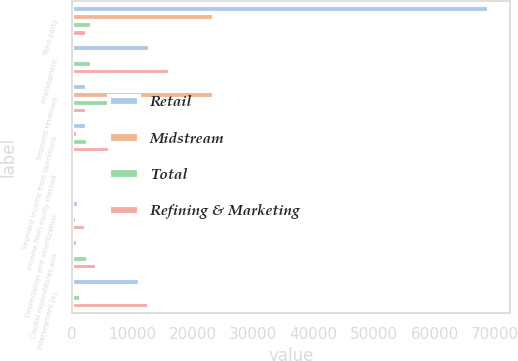Convert chart to OTSL. <chart><loc_0><loc_0><loc_500><loc_500><stacked_bar_chart><ecel><fcel>Third party<fcel>Intersegment<fcel>Segment revenues<fcel>Segment income from operations<fcel>Income from equity method<fcel>Depreciation and amortization<fcel>Capital expenditures and<fcel>Intersegment (a)<nl><fcel>Retail<fcel>68939<fcel>12914<fcel>2481<fcel>2481<fcel>15<fcel>1174<fcel>1057<fcel>11309<nl><fcel>Midstream<fcel>23538<fcel>6<fcel>23552<fcel>1028<fcel>74<fcel>353<fcel>460<fcel>4<nl><fcel>Total<fcel>3273<fcel>3387<fcel>6660<fcel>2752<fcel>274<fcel>885<fcel>2630<fcel>1443<nl><fcel>Refining & Marketing<fcel>2481<fcel>16307<fcel>2481<fcel>6261<fcel>363<fcel>2412<fcel>4147<fcel>12756<nl></chart> 